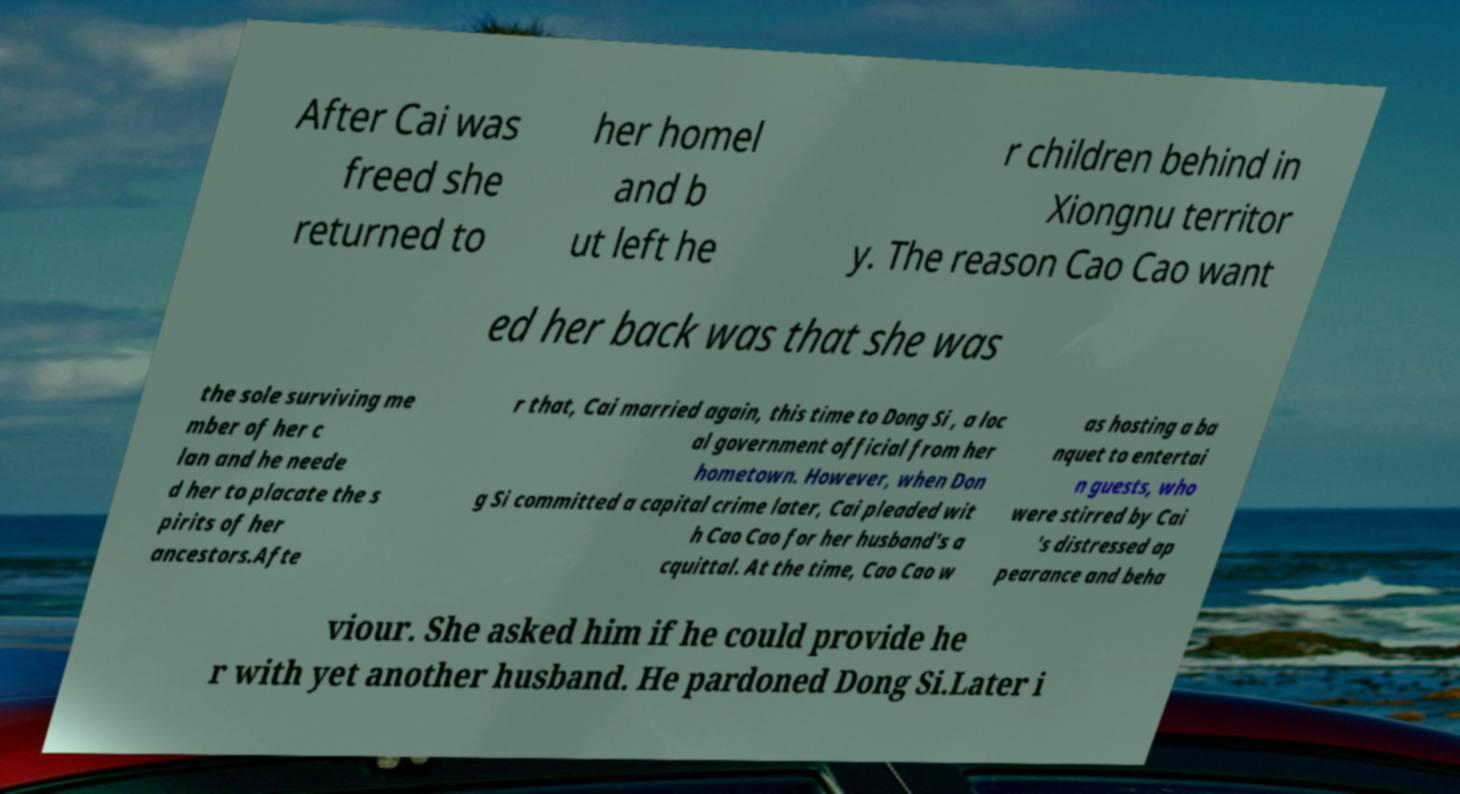What messages or text are displayed in this image? I need them in a readable, typed format. After Cai was freed she returned to her homel and b ut left he r children behind in Xiongnu territor y. The reason Cao Cao want ed her back was that she was the sole surviving me mber of her c lan and he neede d her to placate the s pirits of her ancestors.Afte r that, Cai married again, this time to Dong Si , a loc al government official from her hometown. However, when Don g Si committed a capital crime later, Cai pleaded wit h Cao Cao for her husband's a cquittal. At the time, Cao Cao w as hosting a ba nquet to entertai n guests, who were stirred by Cai 's distressed ap pearance and beha viour. She asked him if he could provide he r with yet another husband. He pardoned Dong Si.Later i 